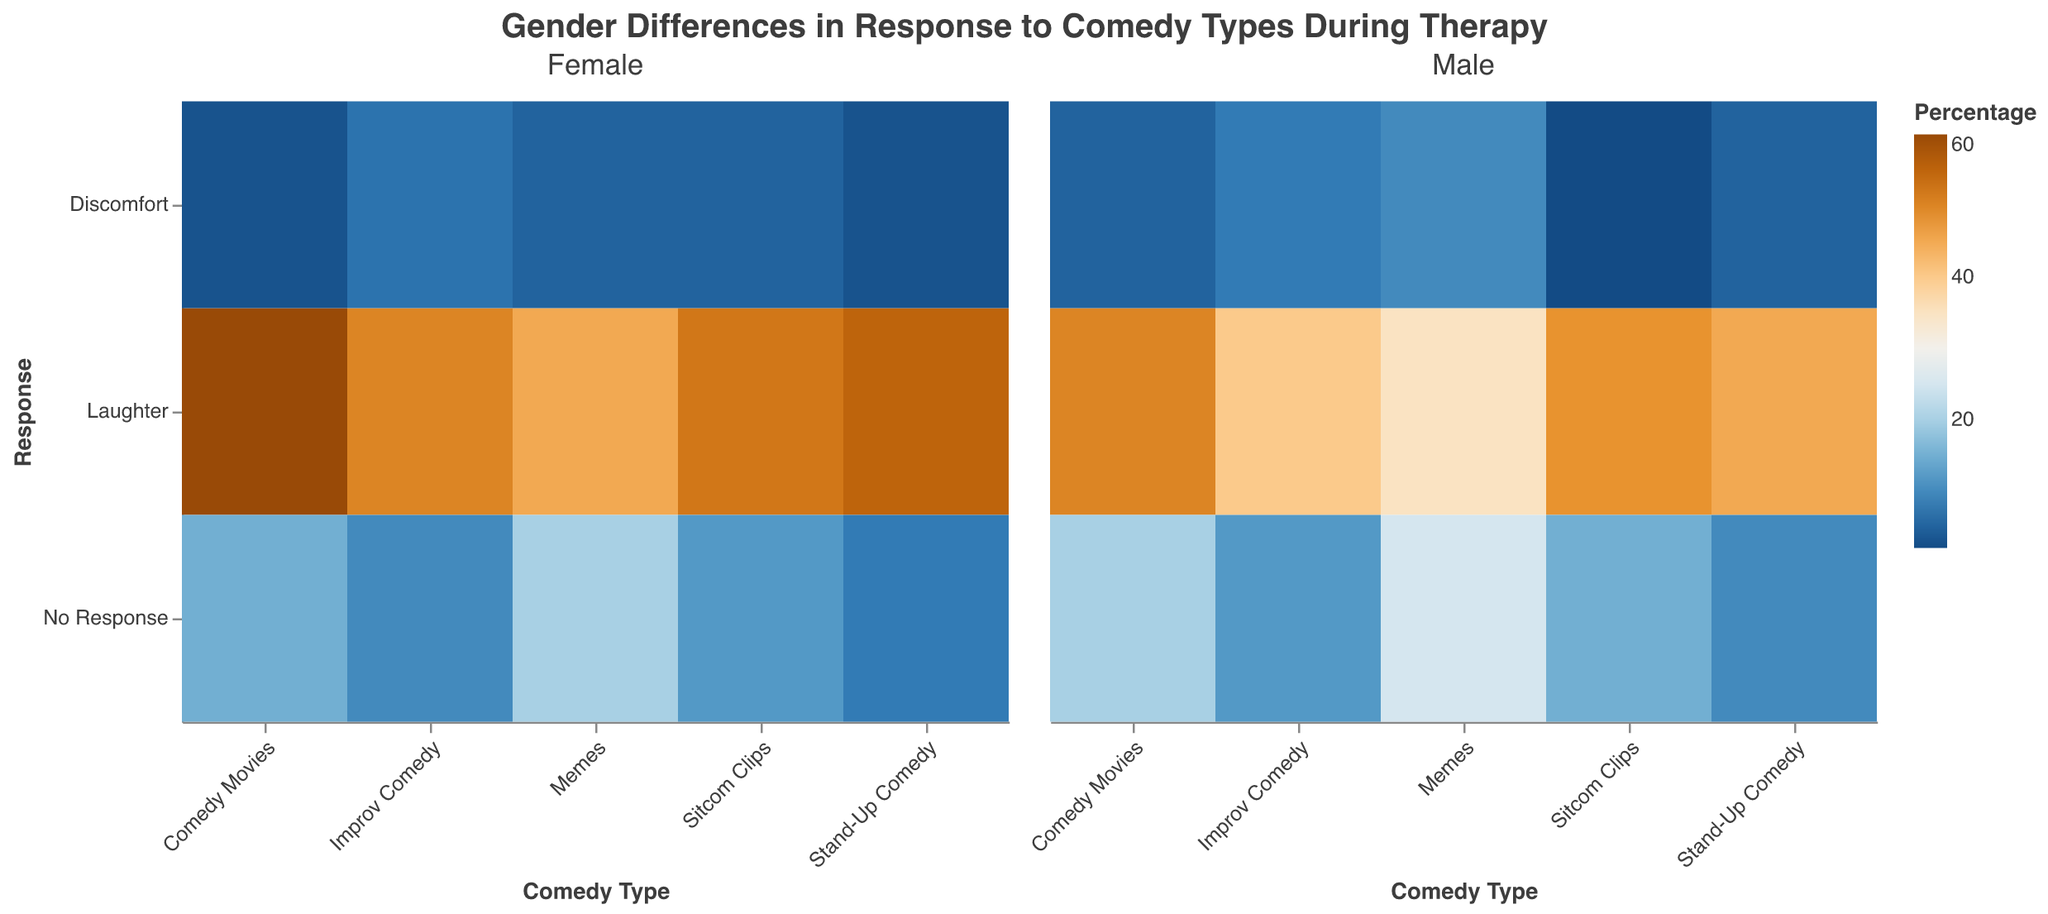What's the title of the heatmap? The title is usually found at the top of the heatmap. In this case, the provided title is "Gender Differences in Response to Comedy Types During Therapy".
Answer: Gender Differences in Response to Comedy Types During Therapy Which comedy type results in the highest percentage of laughter in females? Look for the comedy type with the darkest color in the heatmap at the intersection of "Laughter" and "Female". Comedy Movies have the highest percentage at 60%.
Answer: Comedy Movies What percentage of males had no response to memes? Look at the color intensity and the value in the intersection of "Memes" and "No Response" for "Male". The percentage is 25%.
Answer: 25% Which gender shows more discomfort to Improv Comedy? Compare the percentages at the intersection of "Improv Comedy" and "Discomfort" for both "Male" and "Female". Males show more discomfort at 8%, while females are at 7%.
Answer: Male What is the overall trend of response to Stand-Up Comedy between males and females? Observe the color gradients in the cells corresponding to "Stand-Up Comedy" for both genders across all responses. Females generally show more laughter and less discomfort compared to males.
Answer: Females show more laughter and slightly less discomfort How does the percentage of laughter in males differ between Stand-Up Comedy and Sitcom Clips? Compare the percentage values at the intersection of "Laughter" for "Male" with "Stand-Up Comedy" and "Sitcom Clips". Stand-Up Comedy has 45%, and Sitcom Clips have 48%, a difference of 3%.
Answer: 3% Which comedy type has the smallest percentage of discomfort for both genders? Look for the lightest color (indicating the smallest percentage) in the "Discomfort" row. Sitcom Clips for males show the smallest percentage at 2%.
Answer: Sitcom Clips (Male) What's the combined percentage of females showing no response to Stand-Up Comedy and Comedy Movies? Add the percentage of females showing "No Response" to "Stand-Up Comedy" (8%) and "Comedy Movies" (15%). 8 + 15 = 23.
Answer: 23% Do males or females respond with more laughter to Memes? Compare the percentage in the "Laughter" row for "Memes" between males and females. Females have a higher percentage (45%) compared to males (35%).
Answer: Females Across all comedy types, which gender shows a higher percentage of response labeled as "No Response"? Sum up the percentages of "No Response" across all comedy types for both genders and compare. For males: 10+12+15+20+25 = 82%. For females: 8+10+12+15+20 = 65%. Males show a higher overall percentage.
Answer: Male 